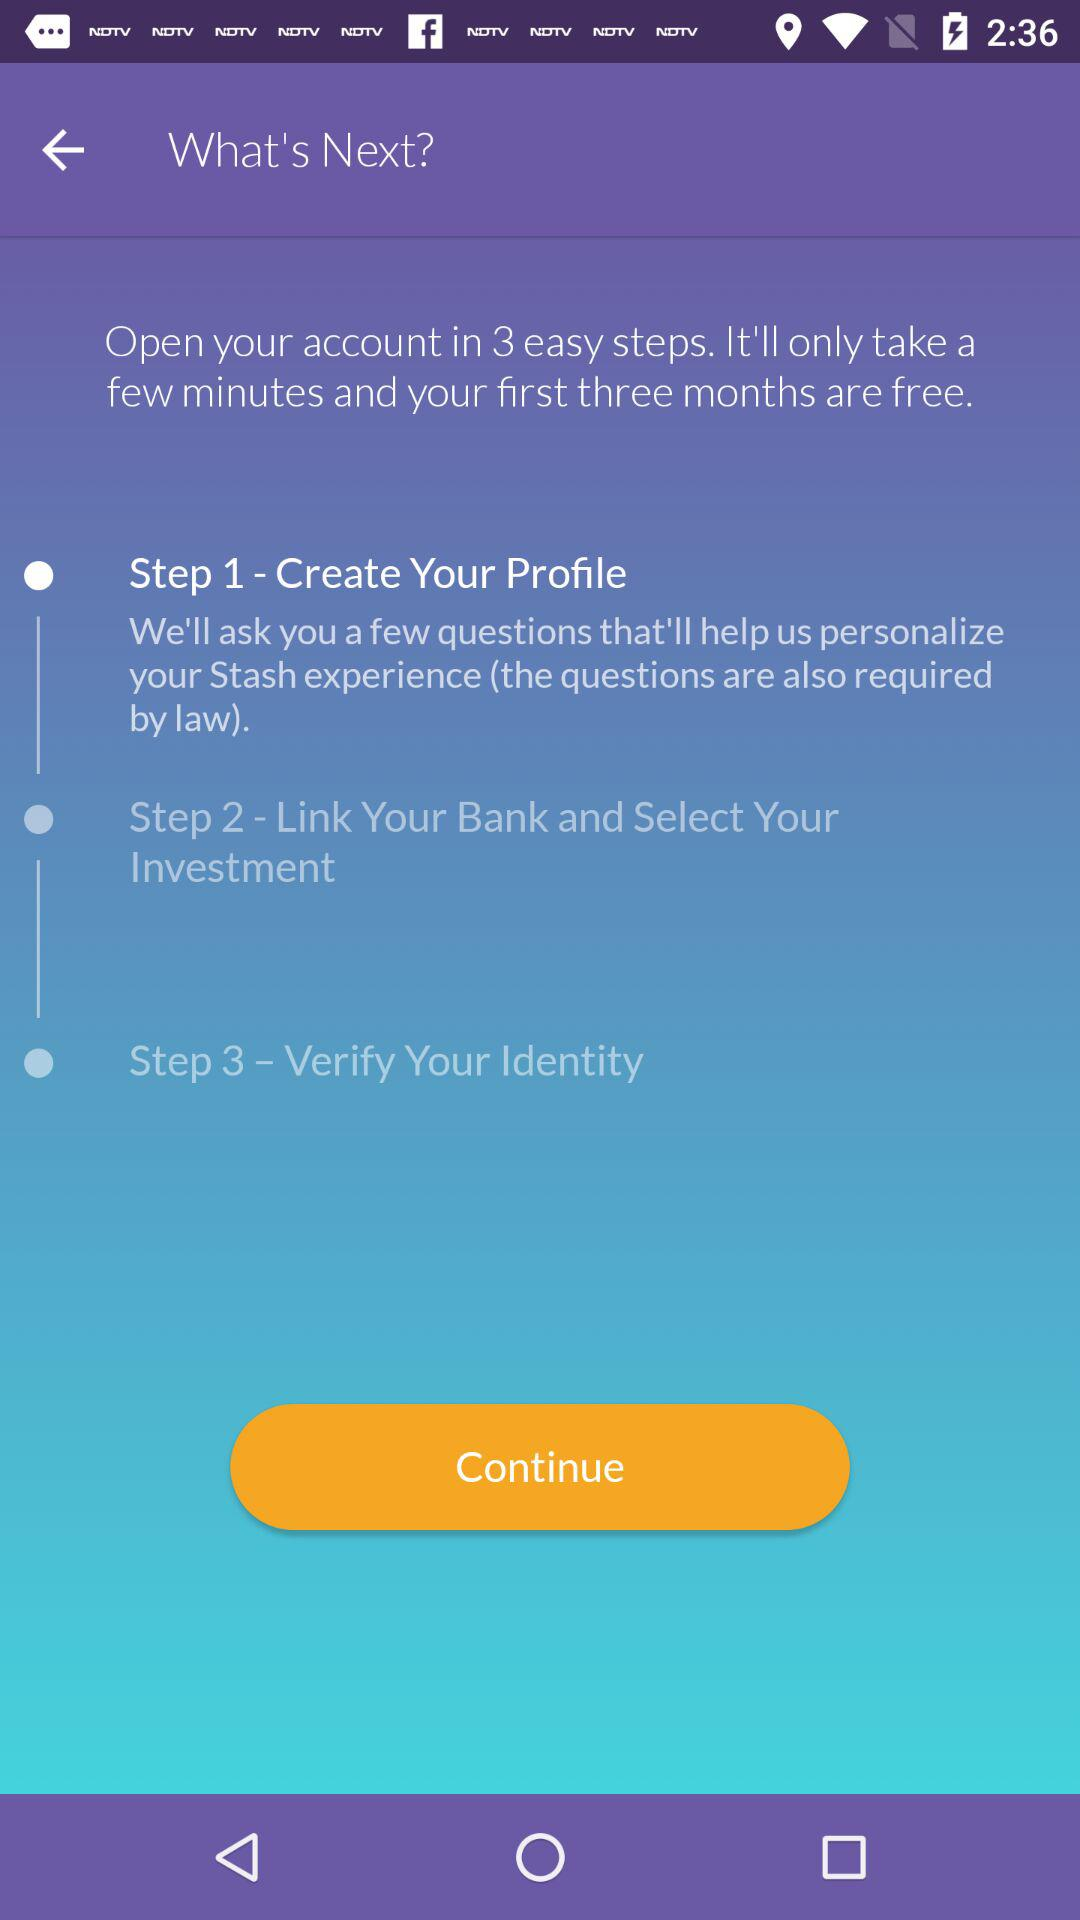How many months are free after opening the account? After opening the account, the first three months are free. 